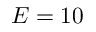Convert formula to latex. <formula><loc_0><loc_0><loc_500><loc_500>E = 1 0</formula> 